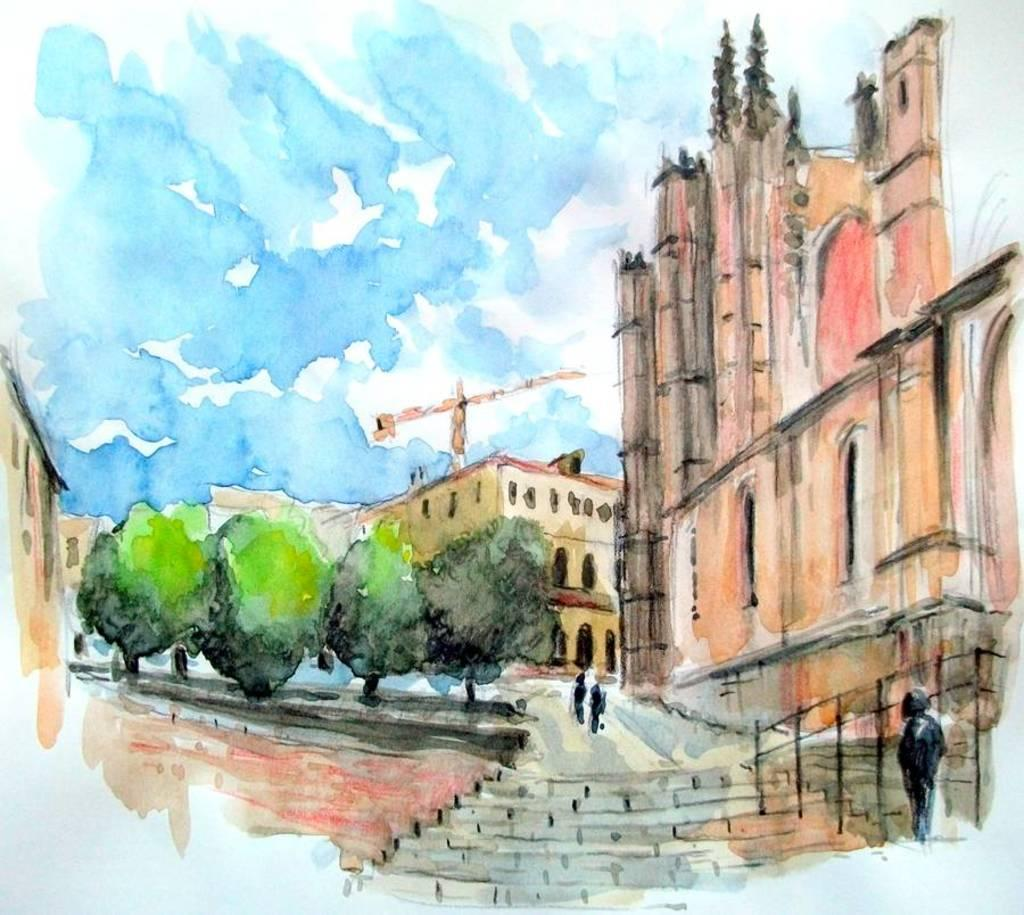What is the main subject of the image? The image contains a painting. What is being depicted in the painting? The painting depicts buildings, trees, and people. How many jellyfish can be seen swimming in the painting? There are no jellyfish present in the painting; it depicts buildings, trees, and people. 